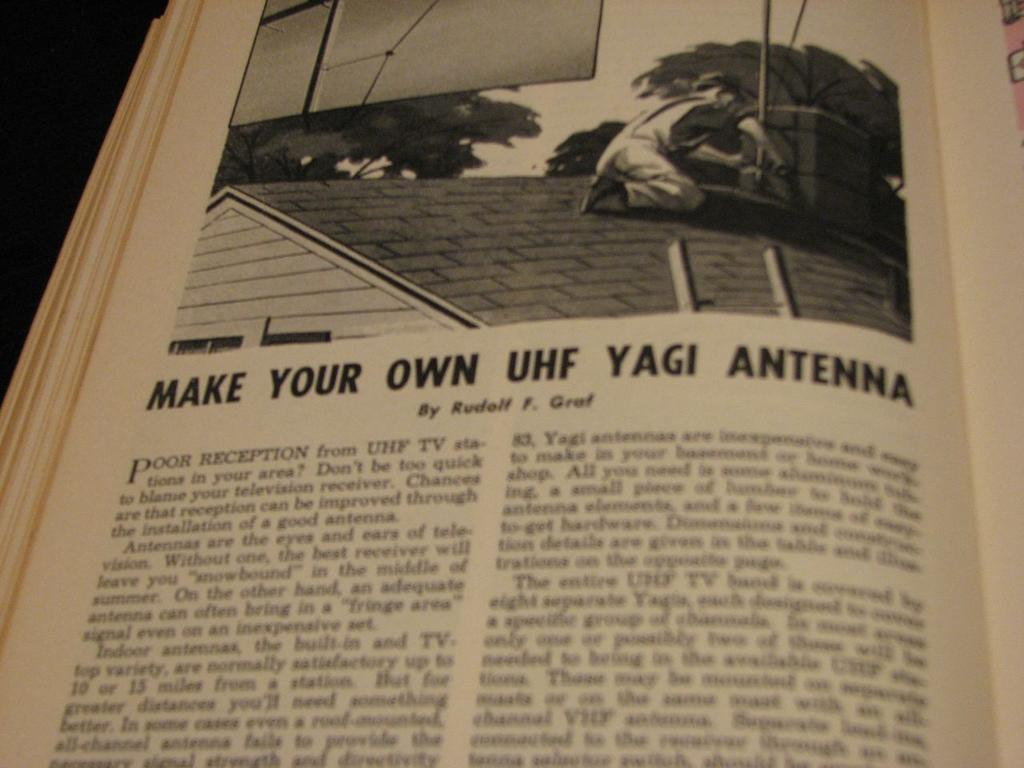<image>
Give a short and clear explanation of the subsequent image. A page on a book advising people how to make their own UHF yagi antenna 